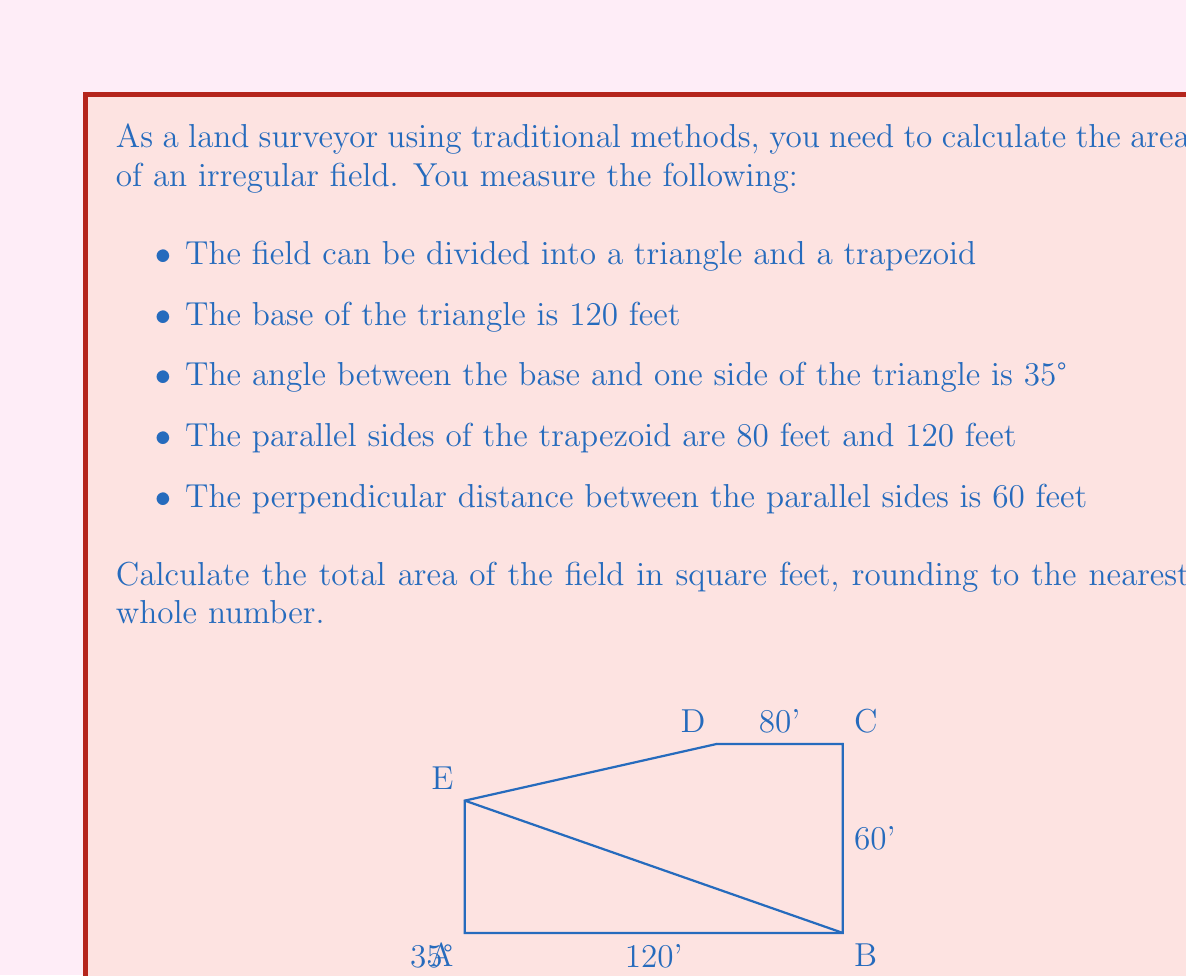Give your solution to this math problem. Let's solve this problem step by step:

1) First, let's calculate the area of the triangle:
   - We know the base (b) is 120 feet and one angle is 35°
   - We need to find the height (h) of the triangle
   - Using trigonometry: $\tan(35°) = \frac{h}{120}$
   - $h = 120 \tan(35°) = 120 \cdot 0.7002 = 84.024$ feet
   - Area of triangle = $\frac{1}{2} \cdot b \cdot h = \frac{1}{2} \cdot 120 \cdot 84.024 = 5041.44$ sq ft

2) Now, let's calculate the area of the trapezoid:
   - We have parallel sides of 80 feet and 120 feet
   - The height is 60 feet
   - Area of trapezoid = $\frac{1}{2}(a+b)h = \frac{1}{2}(80+120) \cdot 60 = 6000$ sq ft

3) Total area is the sum of these two areas:
   $5041.44 + 6000 = 11041.44$ sq ft

4) Rounding to the nearest whole number:
   $11041.44 \approx 11041$ sq ft
Answer: 11041 sq ft 